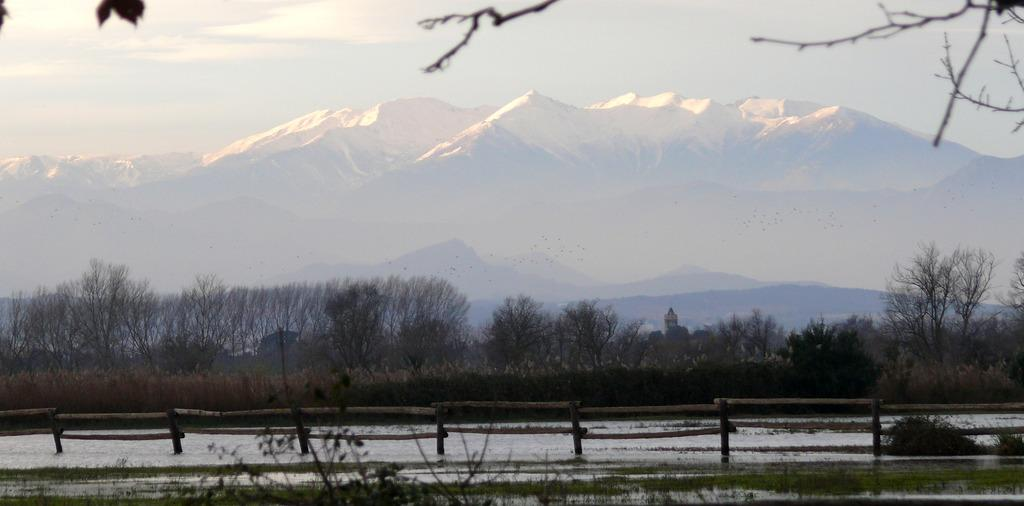What type of barrier can be seen in the image? There is a fence in the image. What natural element is visible in the image? Water is visible in the image. What type of vegetation is present in the image? There are plants and trees in the image. What geographical feature can be seen in the image? There are mountains in the image. What is visible in the background of the image? The sky is visible in the background of the image. What type of utensil is being used to fly the kite in the image? There is no kite or utensil present in the image. How does the feeling of happiness manifest itself in the image? The image does not convey emotions or feelings; it is a visual representation of the landscape. 